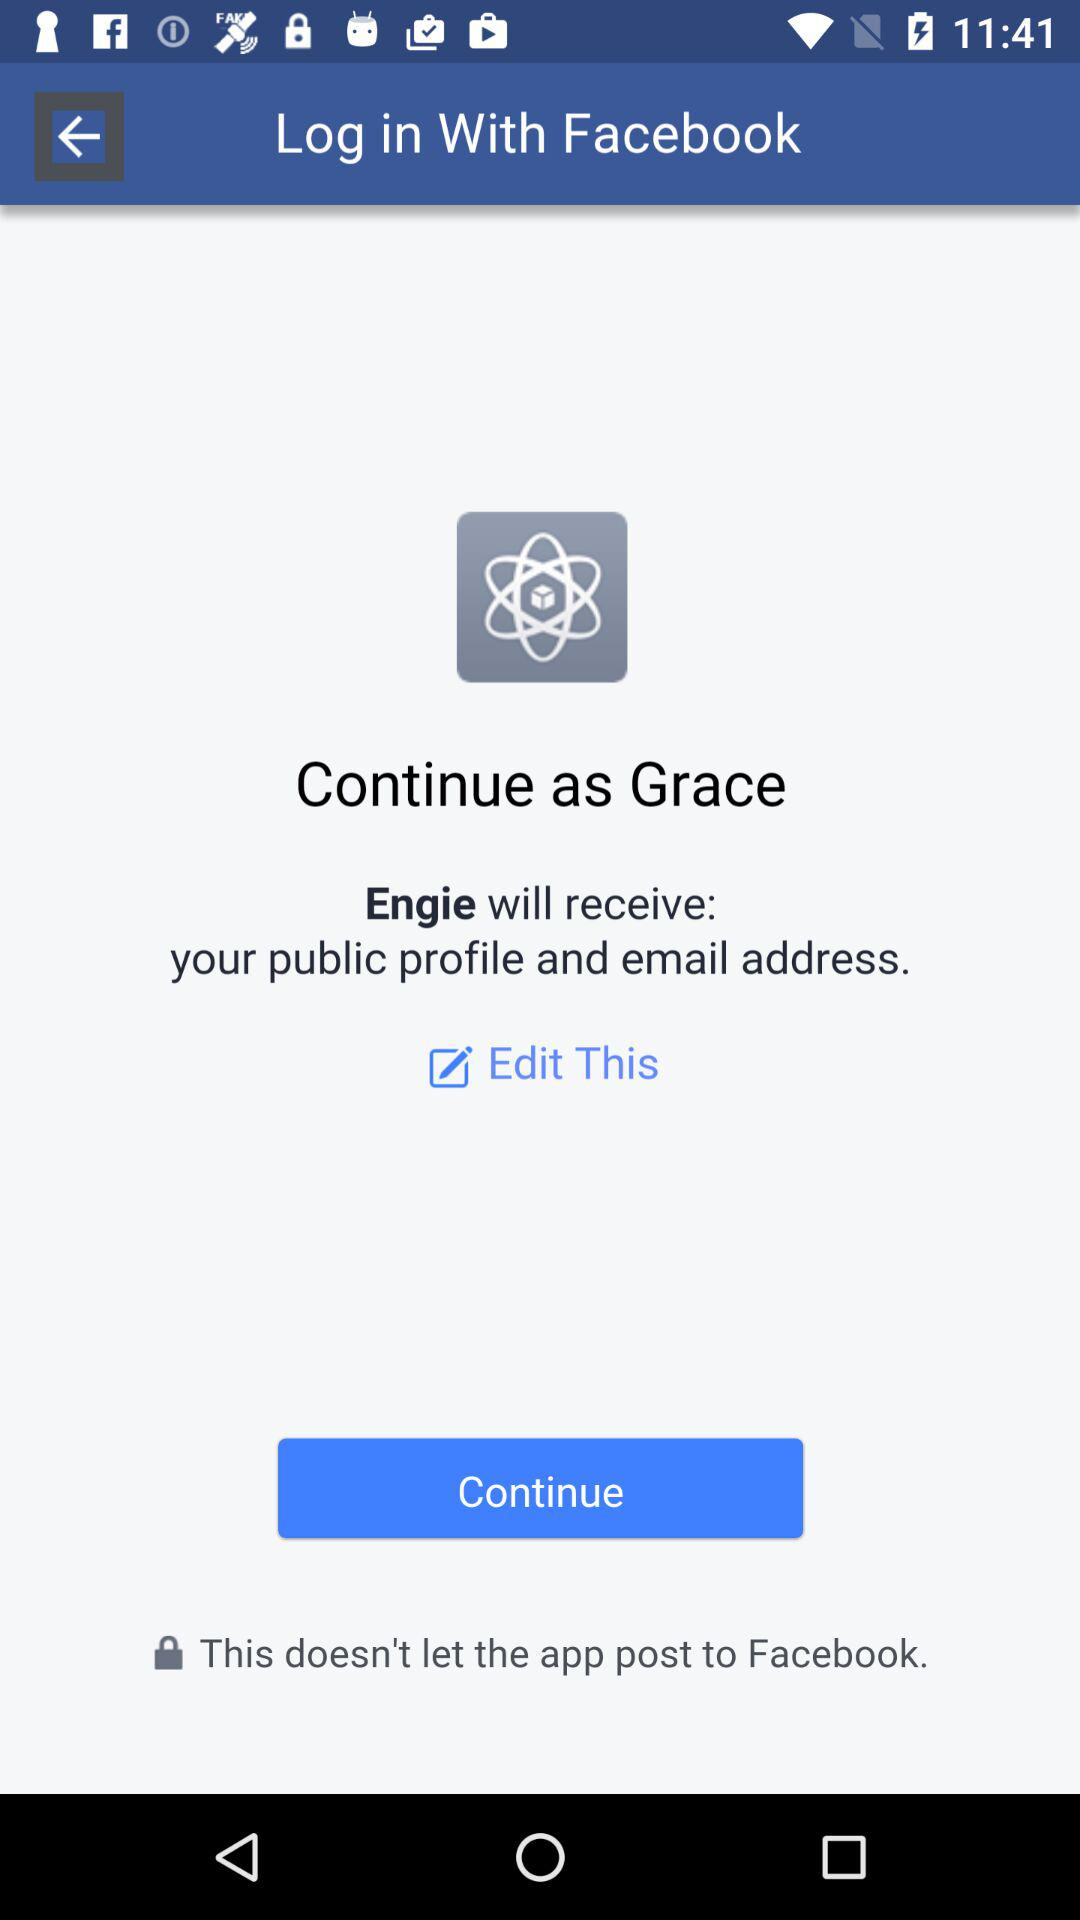What is the name of the user? The name of the user is Grace. 